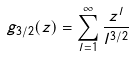<formula> <loc_0><loc_0><loc_500><loc_500>g _ { 3 / 2 } ( z ) = \sum _ { l = 1 } ^ { \infty } \frac { z ^ { l } } { l ^ { 3 / 2 } }</formula> 